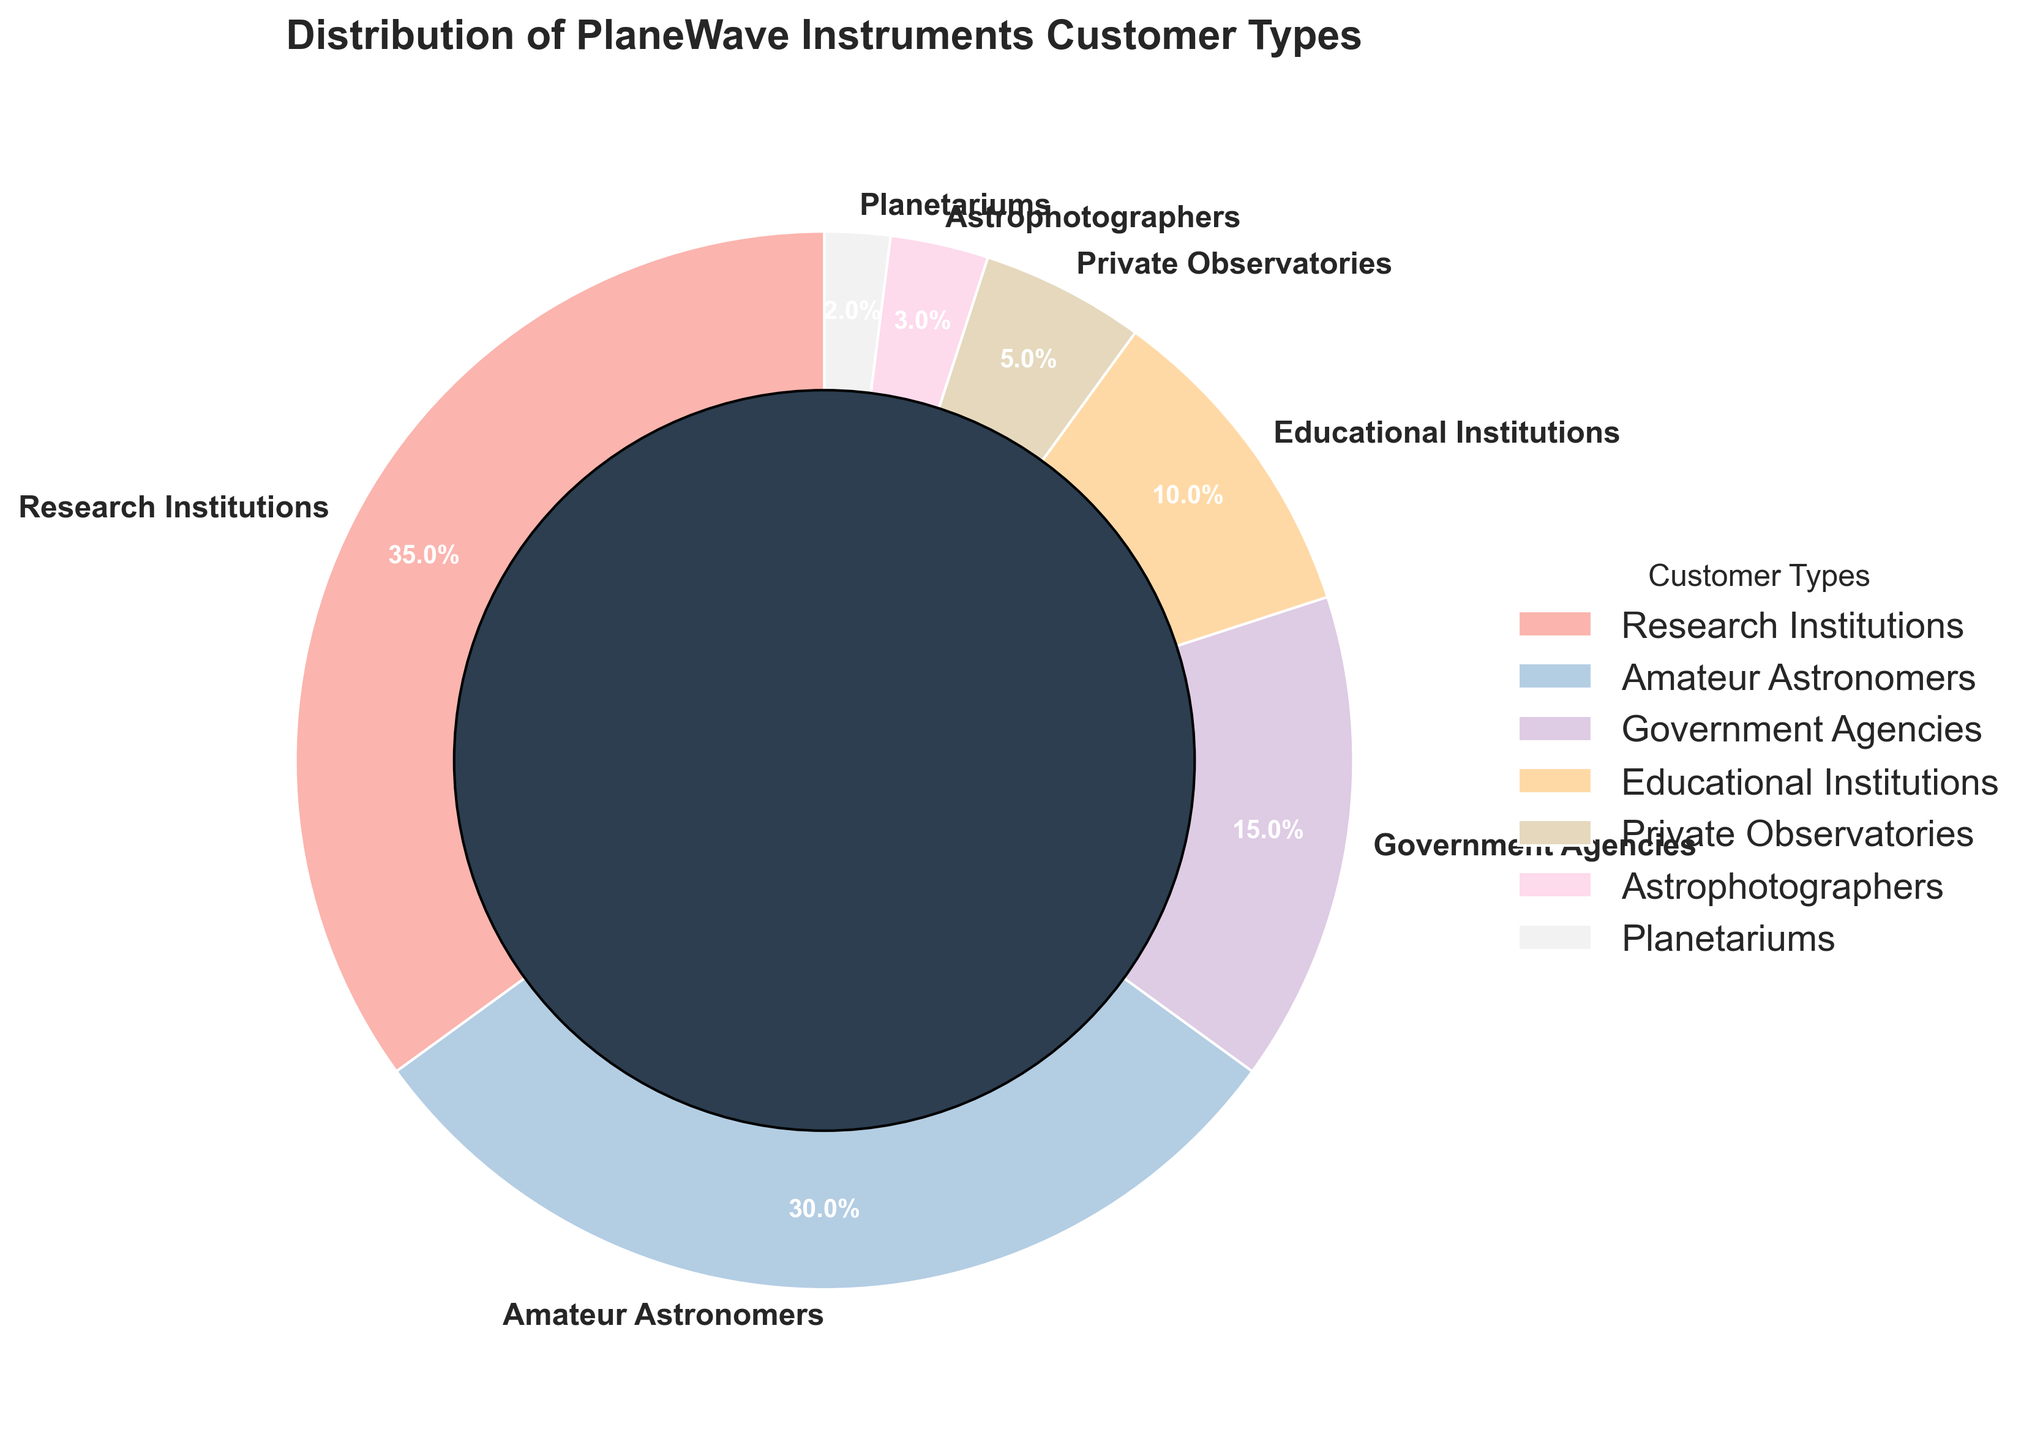What's the most common customer type for PlaneWave Instruments? The customer type with the largest percentage segment in the pie chart is the most common. From the figure, Research Institutions account for 35%, which is the largest segment.
Answer: Research Institutions Which customer type has a smaller percentage than Educational Institutions but larger than Planetariums? We need to identify the customer type between the percentages of Educational Institutions (10%) and Planetariums (2%). Private Observatories fit this criterion, accounting for 5%.
Answer: Private Observatories What is the combined percentage of Government Agencies and Planetariums? By adding the percentages of Government Agencies (15%) and Planetariums (2%), we get 17%.
Answer: 17% What's the percentage difference between Research Institutions and Amateur Astronomers? Subtract the percentage of Amateur Astronomers (30%) from Research Institutions (35%). The difference is 35% - 30% = 5%.
Answer: 5% Which three customer types together constitute less than 20% of the total distribution? We need to find three types whose cumulative percentage is less than 20%. The appropriate ones are Astrophotographers (3%), Planetariums (2%), and Private Observatories (5%), totaling 10%.
Answer: Astrophotographers, Planetariums, Private Observatories Which customer type is represented by the smallest segment in the pie chart? The customer type with the smallest percentage is the smallest segment. Planetariums, with 2%, are the smallest.
Answer: Planetariums Which customer type is directly opposite to Research Institutions in the pie chart? Research Institutions start at 90 degrees. The opposite should start at approximately 270 degrees, which corresponds to Educational Institutions (10%).
Answer: Educational Institutions 